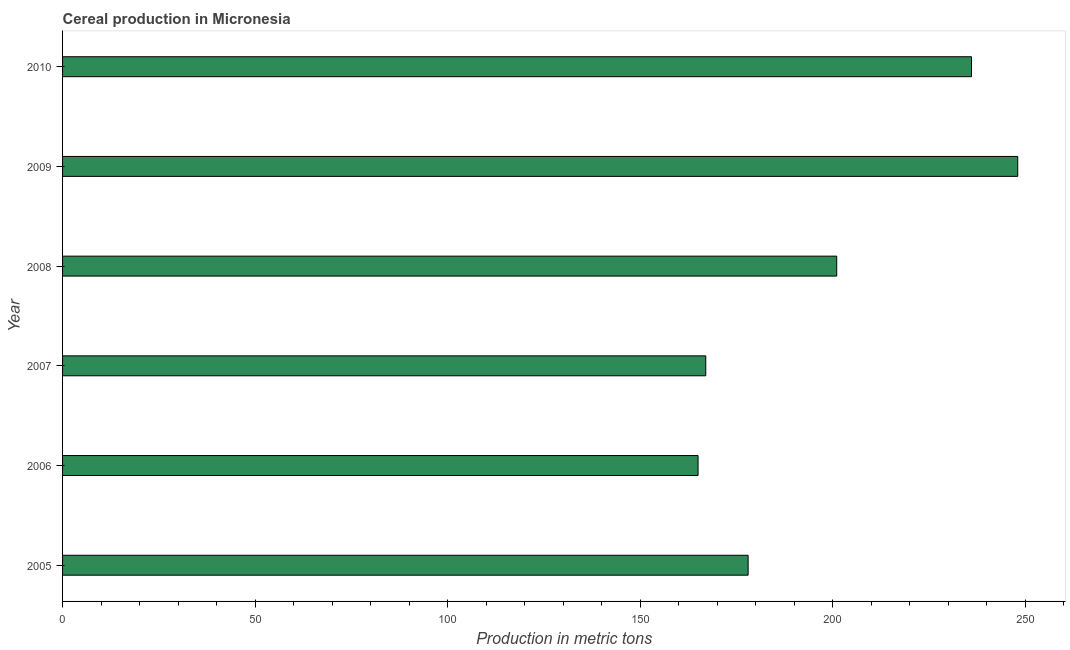Does the graph contain any zero values?
Your response must be concise. No. What is the title of the graph?
Your response must be concise. Cereal production in Micronesia. What is the label or title of the X-axis?
Your answer should be very brief. Production in metric tons. What is the label or title of the Y-axis?
Your answer should be compact. Year. What is the cereal production in 2010?
Ensure brevity in your answer.  236. Across all years, what is the maximum cereal production?
Make the answer very short. 248. Across all years, what is the minimum cereal production?
Make the answer very short. 165. In which year was the cereal production maximum?
Offer a very short reply. 2009. What is the sum of the cereal production?
Your answer should be compact. 1195. What is the difference between the cereal production in 2007 and 2009?
Offer a terse response. -81. What is the average cereal production per year?
Give a very brief answer. 199. What is the median cereal production?
Your response must be concise. 189.5. What is the ratio of the cereal production in 2005 to that in 2010?
Offer a very short reply. 0.75. What is the difference between the highest and the second highest cereal production?
Offer a terse response. 12. Is the sum of the cereal production in 2007 and 2008 greater than the maximum cereal production across all years?
Offer a terse response. Yes. What is the difference between the highest and the lowest cereal production?
Your answer should be compact. 83. In how many years, is the cereal production greater than the average cereal production taken over all years?
Keep it short and to the point. 3. Are all the bars in the graph horizontal?
Your response must be concise. Yes. Are the values on the major ticks of X-axis written in scientific E-notation?
Make the answer very short. No. What is the Production in metric tons of 2005?
Your answer should be compact. 178. What is the Production in metric tons in 2006?
Your answer should be very brief. 165. What is the Production in metric tons of 2007?
Provide a succinct answer. 167. What is the Production in metric tons of 2008?
Provide a succinct answer. 201. What is the Production in metric tons of 2009?
Offer a terse response. 248. What is the Production in metric tons in 2010?
Provide a short and direct response. 236. What is the difference between the Production in metric tons in 2005 and 2006?
Offer a terse response. 13. What is the difference between the Production in metric tons in 2005 and 2007?
Keep it short and to the point. 11. What is the difference between the Production in metric tons in 2005 and 2009?
Make the answer very short. -70. What is the difference between the Production in metric tons in 2005 and 2010?
Offer a terse response. -58. What is the difference between the Production in metric tons in 2006 and 2007?
Give a very brief answer. -2. What is the difference between the Production in metric tons in 2006 and 2008?
Keep it short and to the point. -36. What is the difference between the Production in metric tons in 2006 and 2009?
Make the answer very short. -83. What is the difference between the Production in metric tons in 2006 and 2010?
Your answer should be compact. -71. What is the difference between the Production in metric tons in 2007 and 2008?
Your answer should be very brief. -34. What is the difference between the Production in metric tons in 2007 and 2009?
Your answer should be very brief. -81. What is the difference between the Production in metric tons in 2007 and 2010?
Offer a very short reply. -69. What is the difference between the Production in metric tons in 2008 and 2009?
Your response must be concise. -47. What is the difference between the Production in metric tons in 2008 and 2010?
Your answer should be very brief. -35. What is the difference between the Production in metric tons in 2009 and 2010?
Provide a succinct answer. 12. What is the ratio of the Production in metric tons in 2005 to that in 2006?
Your response must be concise. 1.08. What is the ratio of the Production in metric tons in 2005 to that in 2007?
Provide a short and direct response. 1.07. What is the ratio of the Production in metric tons in 2005 to that in 2008?
Offer a very short reply. 0.89. What is the ratio of the Production in metric tons in 2005 to that in 2009?
Give a very brief answer. 0.72. What is the ratio of the Production in metric tons in 2005 to that in 2010?
Your answer should be compact. 0.75. What is the ratio of the Production in metric tons in 2006 to that in 2007?
Your answer should be compact. 0.99. What is the ratio of the Production in metric tons in 2006 to that in 2008?
Ensure brevity in your answer.  0.82. What is the ratio of the Production in metric tons in 2006 to that in 2009?
Make the answer very short. 0.67. What is the ratio of the Production in metric tons in 2006 to that in 2010?
Provide a short and direct response. 0.7. What is the ratio of the Production in metric tons in 2007 to that in 2008?
Ensure brevity in your answer.  0.83. What is the ratio of the Production in metric tons in 2007 to that in 2009?
Ensure brevity in your answer.  0.67. What is the ratio of the Production in metric tons in 2007 to that in 2010?
Your answer should be very brief. 0.71. What is the ratio of the Production in metric tons in 2008 to that in 2009?
Offer a very short reply. 0.81. What is the ratio of the Production in metric tons in 2008 to that in 2010?
Give a very brief answer. 0.85. What is the ratio of the Production in metric tons in 2009 to that in 2010?
Provide a short and direct response. 1.05. 